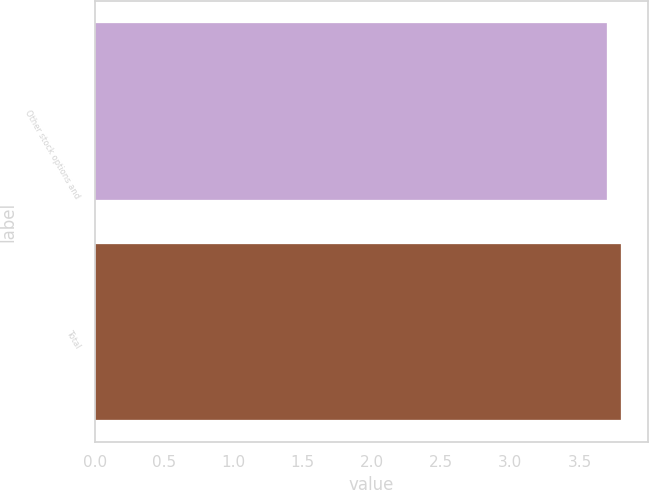Convert chart. <chart><loc_0><loc_0><loc_500><loc_500><bar_chart><fcel>Other stock options and<fcel>Total<nl><fcel>3.7<fcel>3.8<nl></chart> 